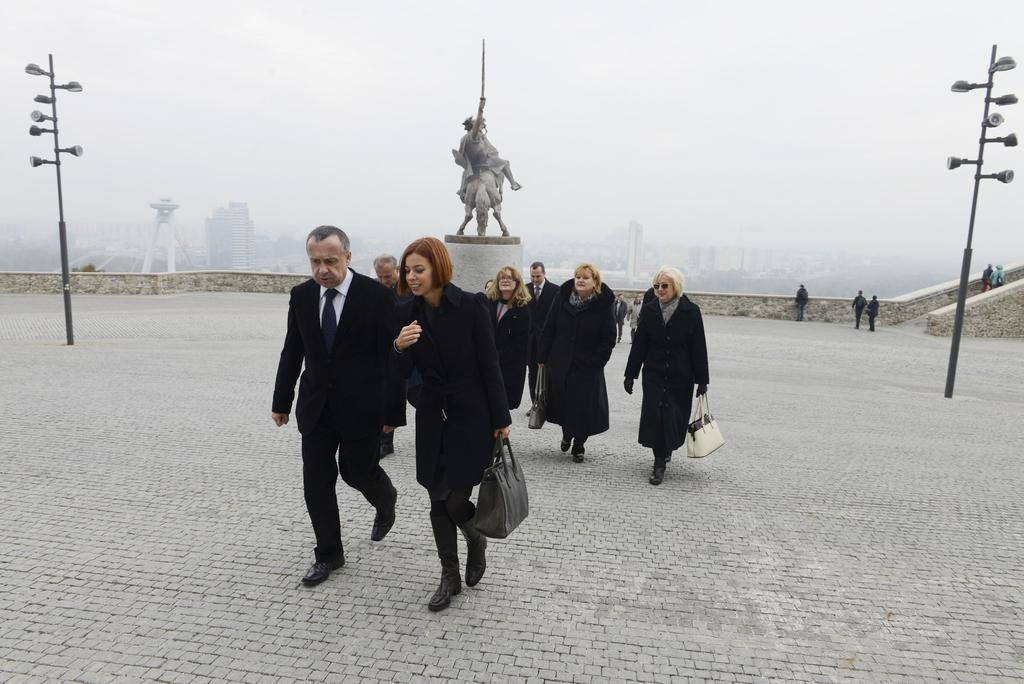What are the people in the image doing? The people in the image are walking on a path. What is located in the middle of the path? There is a statue in the middle of the path. What can be seen on either side of the path? There are poles on either side of the path. What is visible in the background of the image? There is fog visible in the background of the image. What word is being spelled out by the fog in the image? There is no word being spelled out by the fog in the image; it is simply visible in the background. 